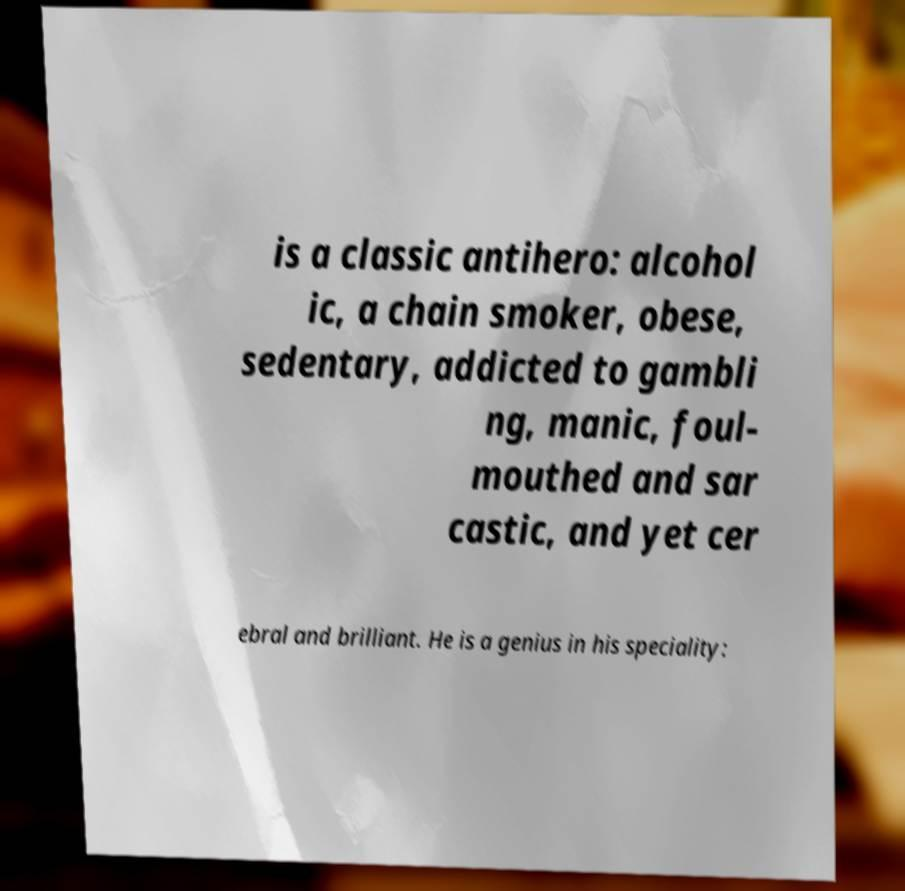I need the written content from this picture converted into text. Can you do that? is a classic antihero: alcohol ic, a chain smoker, obese, sedentary, addicted to gambli ng, manic, foul- mouthed and sar castic, and yet cer ebral and brilliant. He is a genius in his speciality: 